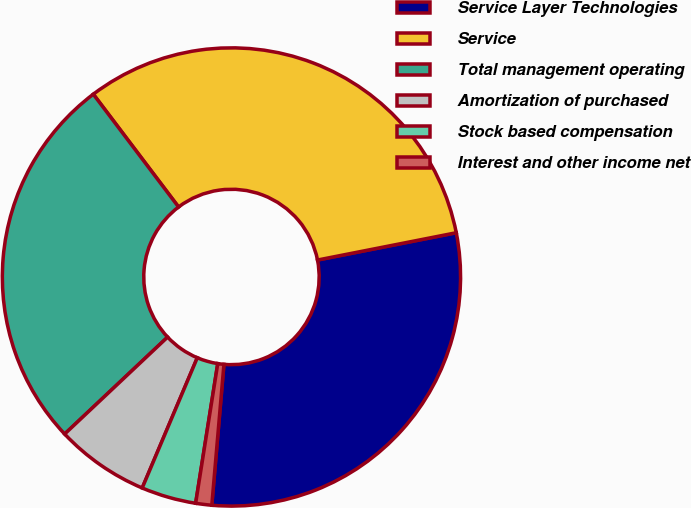<chart> <loc_0><loc_0><loc_500><loc_500><pie_chart><fcel>Service Layer Technologies<fcel>Service<fcel>Total management operating<fcel>Amortization of purchased<fcel>Stock based compensation<fcel>Interest and other income net<nl><fcel>29.46%<fcel>32.21%<fcel>26.72%<fcel>6.61%<fcel>3.87%<fcel>1.13%<nl></chart> 